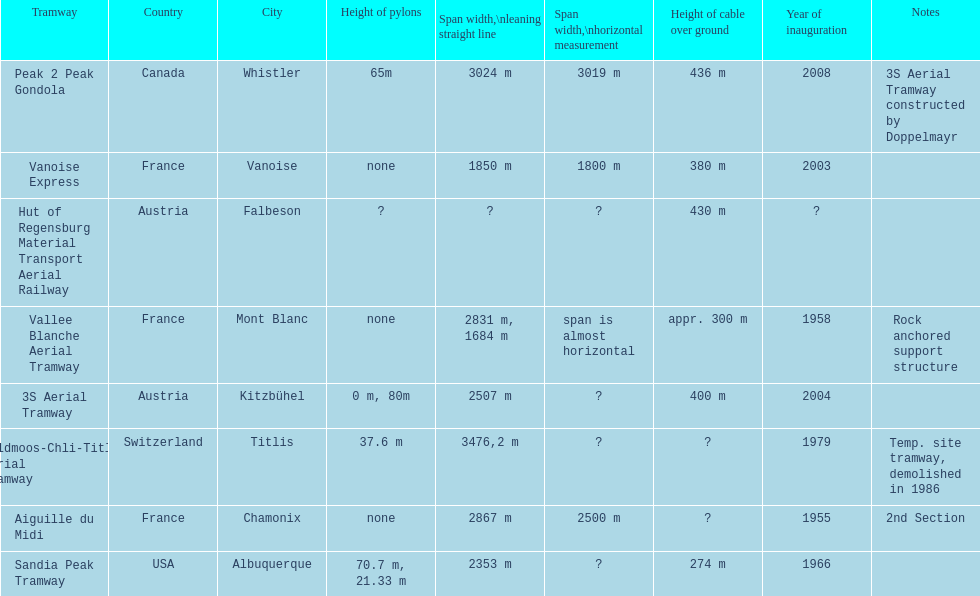Write the full table. {'header': ['Tramway', 'Country', 'City', 'Height of pylons', 'Span\xa0width,\\nleaning straight line', 'Span width,\\nhorizontal measurement', 'Height of cable over ground', 'Year of inauguration', 'Notes'], 'rows': [['Peak 2 Peak Gondola', 'Canada', 'Whistler', '65m', '3024 m', '3019 m', '436 m', '2008', '3S Aerial Tramway constructed by Doppelmayr'], ['Vanoise Express', 'France', 'Vanoise', 'none', '1850 m', '1800 m', '380 m', '2003', ''], ['Hut of Regensburg Material Transport Aerial Railway', 'Austria', 'Falbeson', '?', '?', '?', '430 m', '?', ''], ['Vallee Blanche Aerial Tramway', 'France', 'Mont Blanc', 'none', '2831 m, 1684 m', 'span is almost horizontal', 'appr. 300 m', '1958', 'Rock anchored support structure'], ['3S Aerial Tramway', 'Austria', 'Kitzbühel', '0 m, 80m', '2507 m', '?', '400 m', '2004', ''], ['Feldmoos-Chli-Titlis Aerial Tramway', 'Switzerland', 'Titlis', '37.6 m', '3476,2 m', '?', '?', '1979', 'Temp. site tramway, demolished in 1986'], ['Aiguille du Midi', 'France', 'Chamonix', 'none', '2867 m', '2500 m', '?', '1955', '2nd Section'], ['Sandia Peak Tramway', 'USA', 'Albuquerque', '70.7 m, 21.33 m', '2353 m', '?', '274 m', '1966', '']]} Which tramway was inaugurated first, the 3s aerial tramway or the aiguille du midi? Aiguille du Midi. 